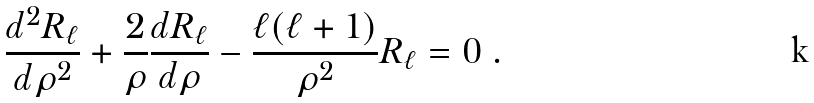Convert formula to latex. <formula><loc_0><loc_0><loc_500><loc_500>\frac { d ^ { 2 } R _ { \ell } } { d \rho ^ { 2 } } + \frac { 2 } { \rho } \frac { d R _ { \ell } } { d \rho } - \frac { \ell ( \ell + 1 ) } { \rho ^ { 2 } } R _ { \ell } = 0 \ .</formula> 